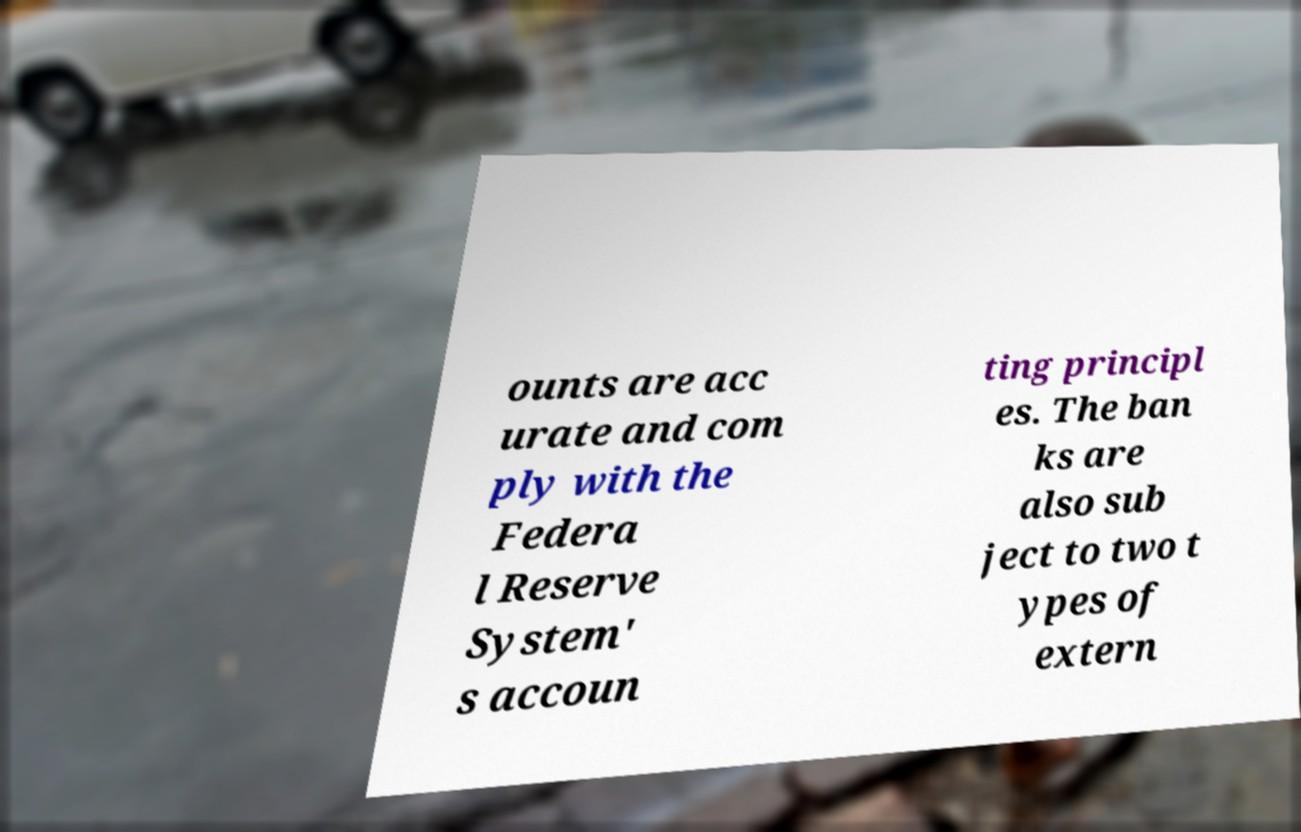Please identify and transcribe the text found in this image. ounts are acc urate and com ply with the Federa l Reserve System' s accoun ting principl es. The ban ks are also sub ject to two t ypes of extern 